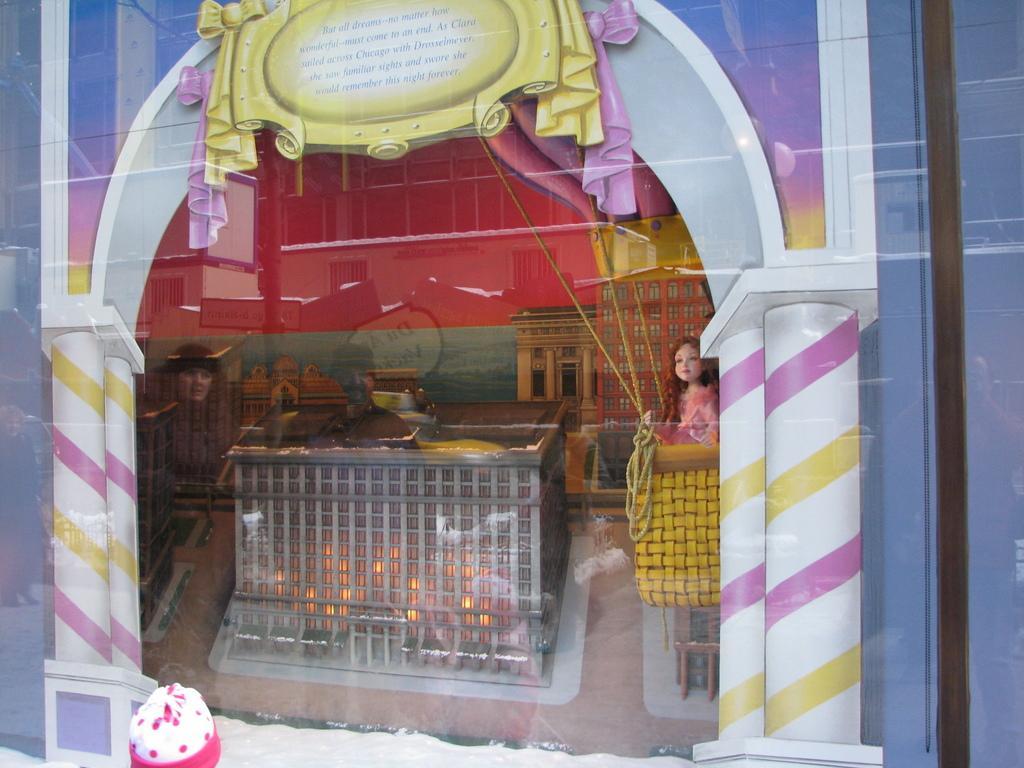Can you describe this image briefly? In this image I can see the miniature of the buildings, background I can see the reflection of few buildings and the wall is in multi color. In front I can see the board in yellow color. 